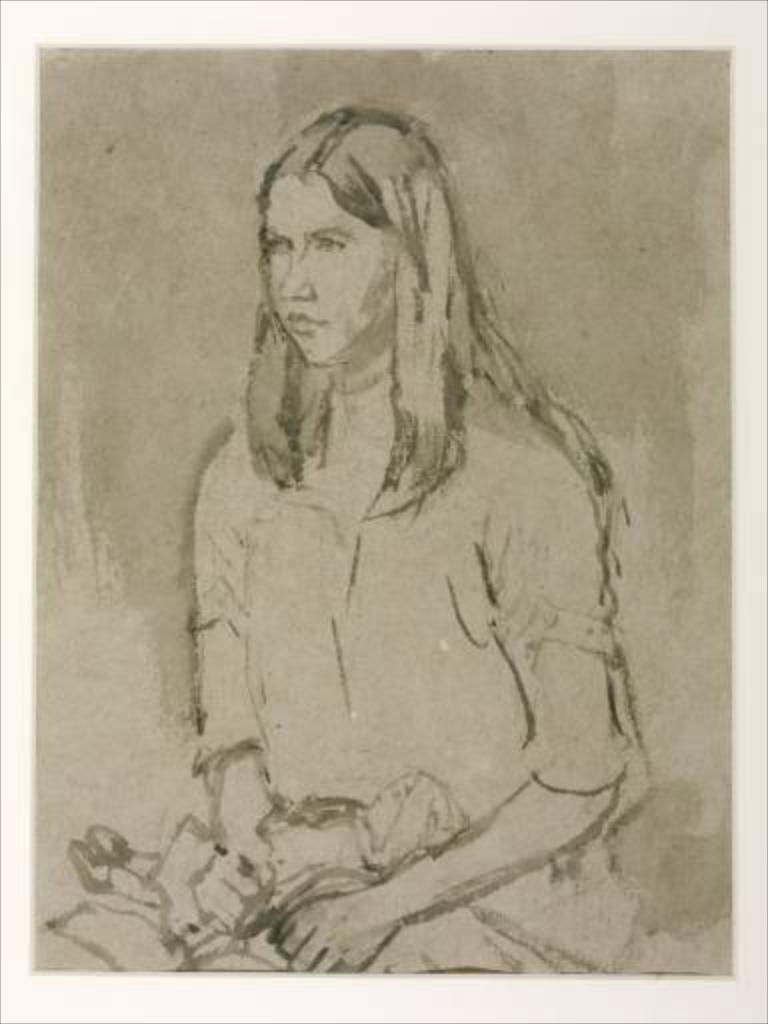What is the main subject of the image? There is a woman sketch in the image. What color is used for the borders of the image? The borders of the image are white in color. What language is the woman speaking in the image? There is no indication of the woman speaking in the image, as it is a sketch. What type of crib is visible in the image? There is no crib present in the image; it features a woman sketch with white borders. 